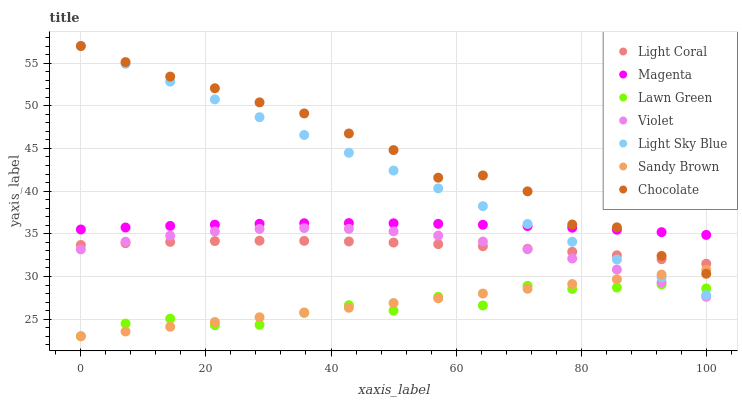Does Lawn Green have the minimum area under the curve?
Answer yes or no. Yes. Does Chocolate have the maximum area under the curve?
Answer yes or no. Yes. Does Light Coral have the minimum area under the curve?
Answer yes or no. No. Does Light Coral have the maximum area under the curve?
Answer yes or no. No. Is Sandy Brown the smoothest?
Answer yes or no. Yes. Is Chocolate the roughest?
Answer yes or no. Yes. Is Light Coral the smoothest?
Answer yes or no. No. Is Light Coral the roughest?
Answer yes or no. No. Does Lawn Green have the lowest value?
Answer yes or no. Yes. Does Chocolate have the lowest value?
Answer yes or no. No. Does Light Sky Blue have the highest value?
Answer yes or no. Yes. Does Light Coral have the highest value?
Answer yes or no. No. Is Sandy Brown less than Light Coral?
Answer yes or no. Yes. Is Magenta greater than Violet?
Answer yes or no. Yes. Does Light Sky Blue intersect Magenta?
Answer yes or no. Yes. Is Light Sky Blue less than Magenta?
Answer yes or no. No. Is Light Sky Blue greater than Magenta?
Answer yes or no. No. Does Sandy Brown intersect Light Coral?
Answer yes or no. No. 